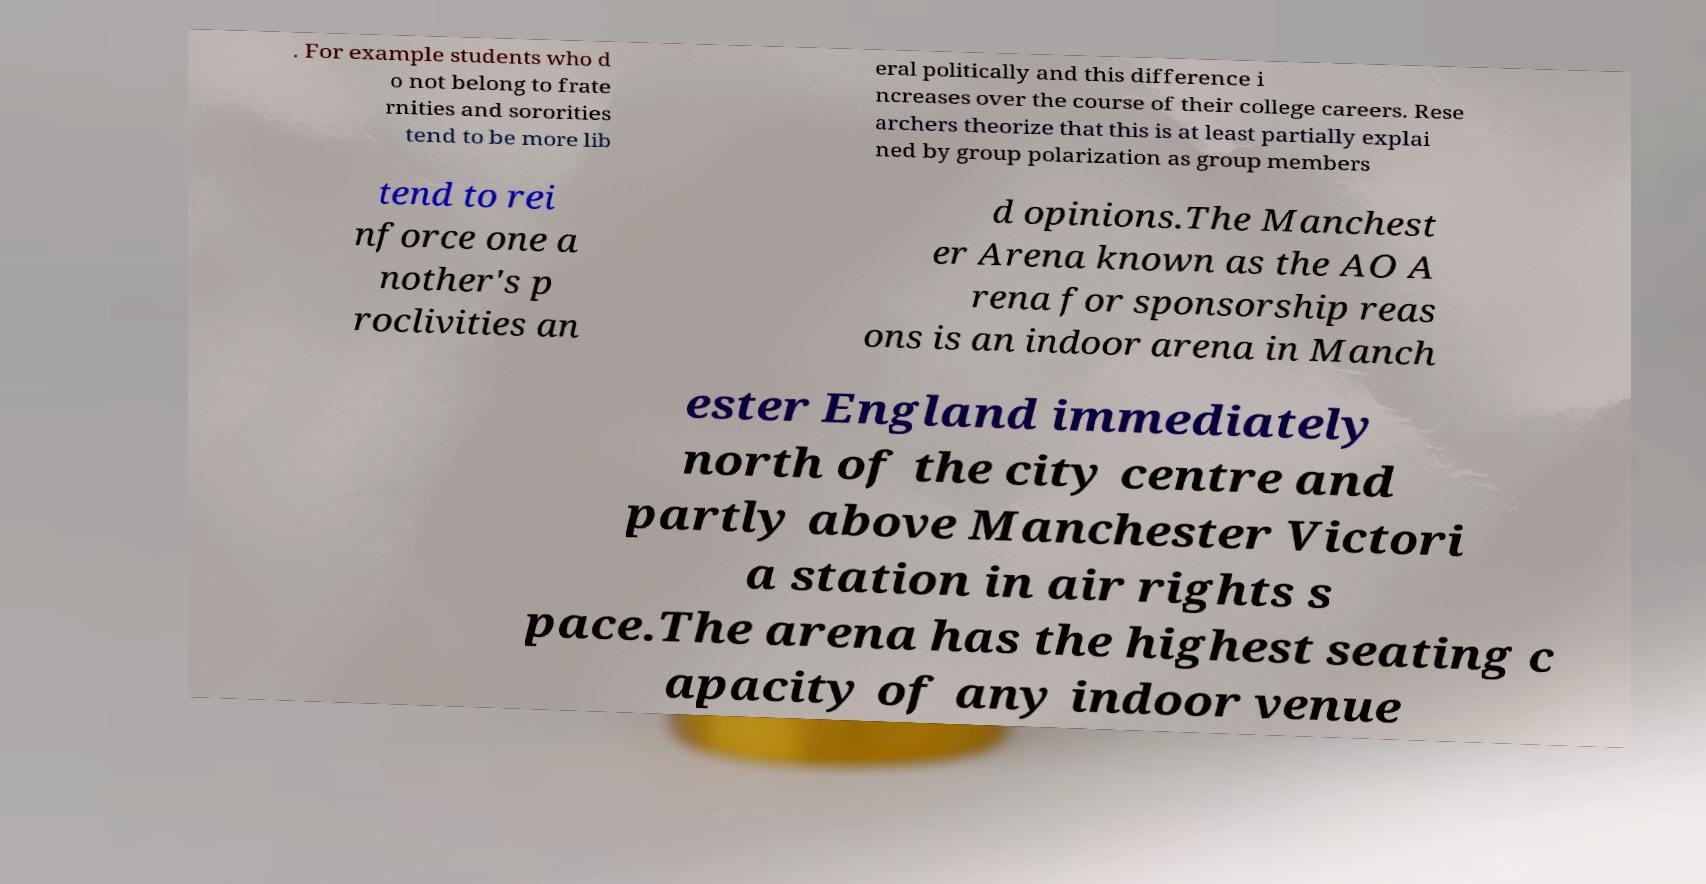Can you accurately transcribe the text from the provided image for me? . For example students who d o not belong to frate rnities and sororities tend to be more lib eral politically and this difference i ncreases over the course of their college careers. Rese archers theorize that this is at least partially explai ned by group polarization as group members tend to rei nforce one a nother's p roclivities an d opinions.The Manchest er Arena known as the AO A rena for sponsorship reas ons is an indoor arena in Manch ester England immediately north of the city centre and partly above Manchester Victori a station in air rights s pace.The arena has the highest seating c apacity of any indoor venue 